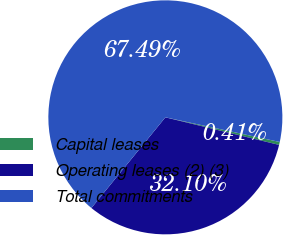Convert chart to OTSL. <chart><loc_0><loc_0><loc_500><loc_500><pie_chart><fcel>Capital leases<fcel>Operating leases (2) (3)<fcel>Total commitments<nl><fcel>0.41%<fcel>32.1%<fcel>67.49%<nl></chart> 